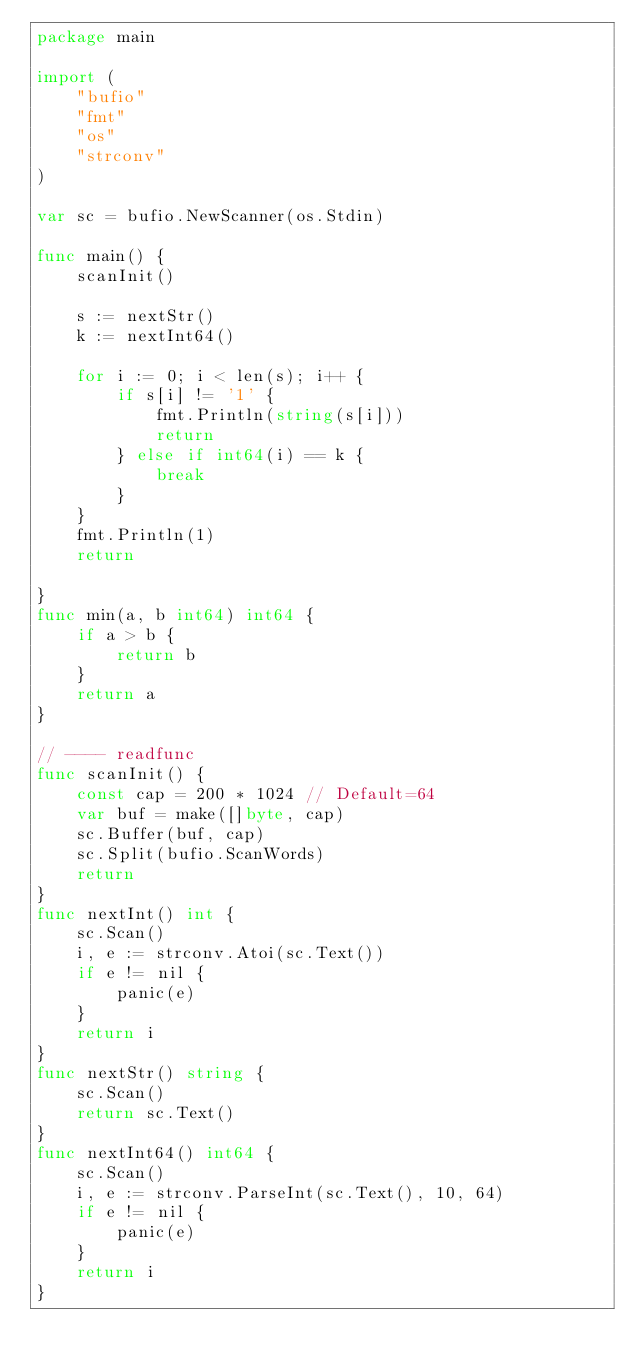Convert code to text. <code><loc_0><loc_0><loc_500><loc_500><_Go_>package main

import (
	"bufio"
	"fmt"
	"os"
	"strconv"
)

var sc = bufio.NewScanner(os.Stdin)

func main() {
	scanInit()

	s := nextStr()
	k := nextInt64()

	for i := 0; i < len(s); i++ {
		if s[i] != '1' {
			fmt.Println(string(s[i]))
			return
		} else if int64(i) == k {
			break
		}
	}
	fmt.Println(1)
	return

}
func min(a, b int64) int64 {
	if a > b {
		return b
	}
	return a
}

// ---- readfunc
func scanInit() {
	const cap = 200 * 1024 // Default=64
	var buf = make([]byte, cap)
	sc.Buffer(buf, cap)
	sc.Split(bufio.ScanWords)
	return
}
func nextInt() int {
	sc.Scan()
	i, e := strconv.Atoi(sc.Text())
	if e != nil {
		panic(e)
	}
	return i
}
func nextStr() string {
	sc.Scan()
	return sc.Text()
}
func nextInt64() int64 {
	sc.Scan()
	i, e := strconv.ParseInt(sc.Text(), 10, 64)
	if e != nil {
		panic(e)
	}
	return i
}
</code> 